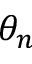Convert formula to latex. <formula><loc_0><loc_0><loc_500><loc_500>\theta _ { n }</formula> 